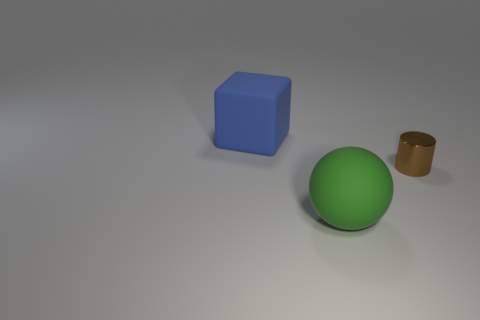Add 2 green matte spheres. How many objects exist? 5 Subtract all cubes. How many objects are left? 2 Add 1 brown metallic cylinders. How many brown metallic cylinders are left? 2 Add 3 large green things. How many large green things exist? 4 Subtract 0 yellow spheres. How many objects are left? 3 Subtract 1 cylinders. How many cylinders are left? 0 Subtract all green blocks. Subtract all yellow balls. How many blocks are left? 1 Subtract all gray cubes. How many red balls are left? 0 Subtract all green matte things. Subtract all large objects. How many objects are left? 0 